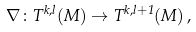<formula> <loc_0><loc_0><loc_500><loc_500>\nabla \colon T ^ { k , l } ( M ) \rightarrow T ^ { k , l + 1 } ( M ) \, ,</formula> 